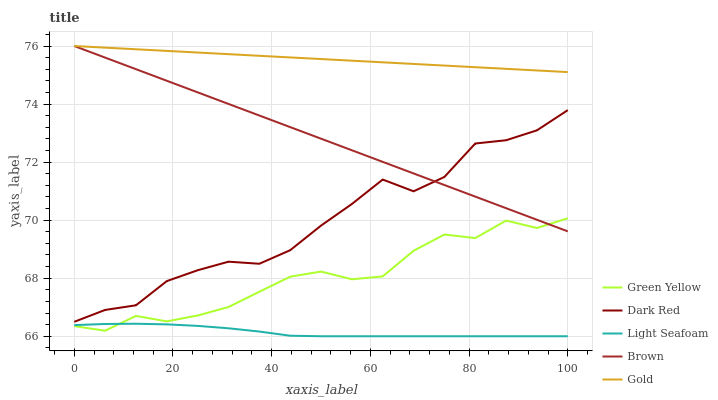Does Light Seafoam have the minimum area under the curve?
Answer yes or no. Yes. Does Gold have the maximum area under the curve?
Answer yes or no. Yes. Does Green Yellow have the minimum area under the curve?
Answer yes or no. No. Does Green Yellow have the maximum area under the curve?
Answer yes or no. No. Is Brown the smoothest?
Answer yes or no. Yes. Is Dark Red the roughest?
Answer yes or no. Yes. Is Green Yellow the smoothest?
Answer yes or no. No. Is Green Yellow the roughest?
Answer yes or no. No. Does Light Seafoam have the lowest value?
Answer yes or no. Yes. Does Green Yellow have the lowest value?
Answer yes or no. No. Does Brown have the highest value?
Answer yes or no. Yes. Does Green Yellow have the highest value?
Answer yes or no. No. Is Light Seafoam less than Brown?
Answer yes or no. Yes. Is Dark Red greater than Light Seafoam?
Answer yes or no. Yes. Does Green Yellow intersect Brown?
Answer yes or no. Yes. Is Green Yellow less than Brown?
Answer yes or no. No. Is Green Yellow greater than Brown?
Answer yes or no. No. Does Light Seafoam intersect Brown?
Answer yes or no. No. 